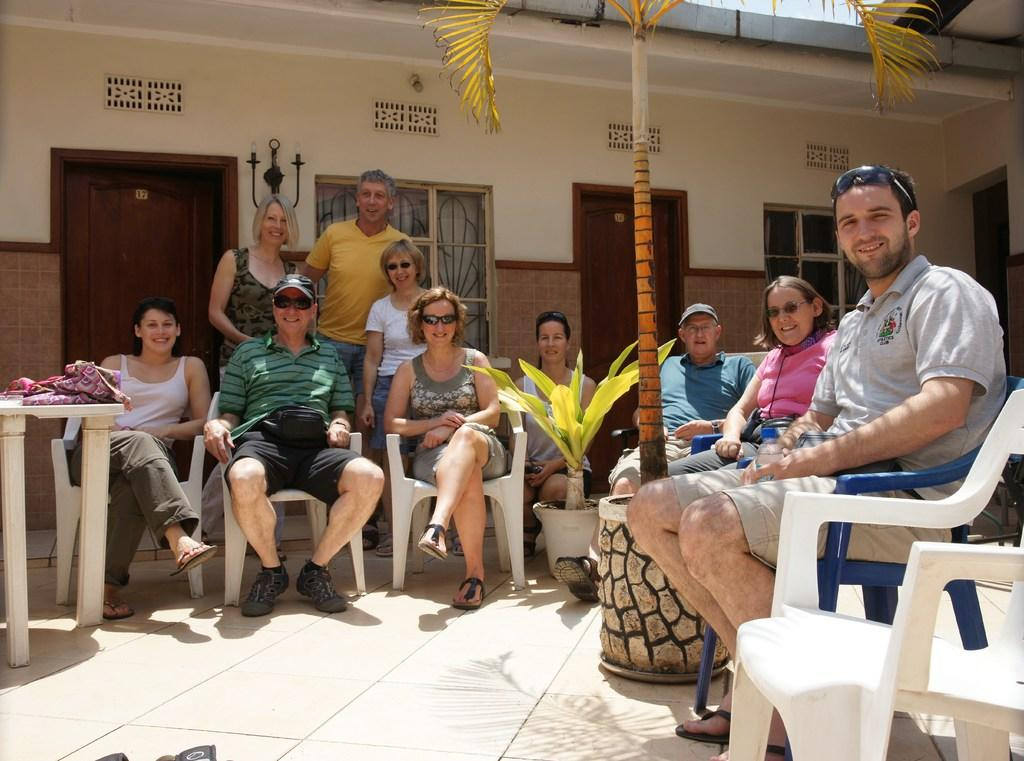What are the people in the image doing? There is a group of people sitting in chairs, and three people are standing behind them. Can you describe the position of the standing people? The three people are standing behind the seated group. What can be seen in the background of the image? There are doors in the background. Reasoning: Let's think step by step by step in order to produce the conversation. We start by identifying the main subjects in the image, which are the people sitting and standing. Then, we describe the position of the standing people in relation to the seated group. Finally, we mention the doors visible in the background. Each question is designed to elicit a specific detail about the image that is known from the provided facts. Absurd Question/Answer: What color is the sock on the leg of the person standing in the image? There is no sock or leg visible in the image; the people are either sitting or standing behind the seated group. What type of observation can be made about the leg of the person standing in the image? There is no leg visible in the image; the people are either sitting or standing behind the seated group. 